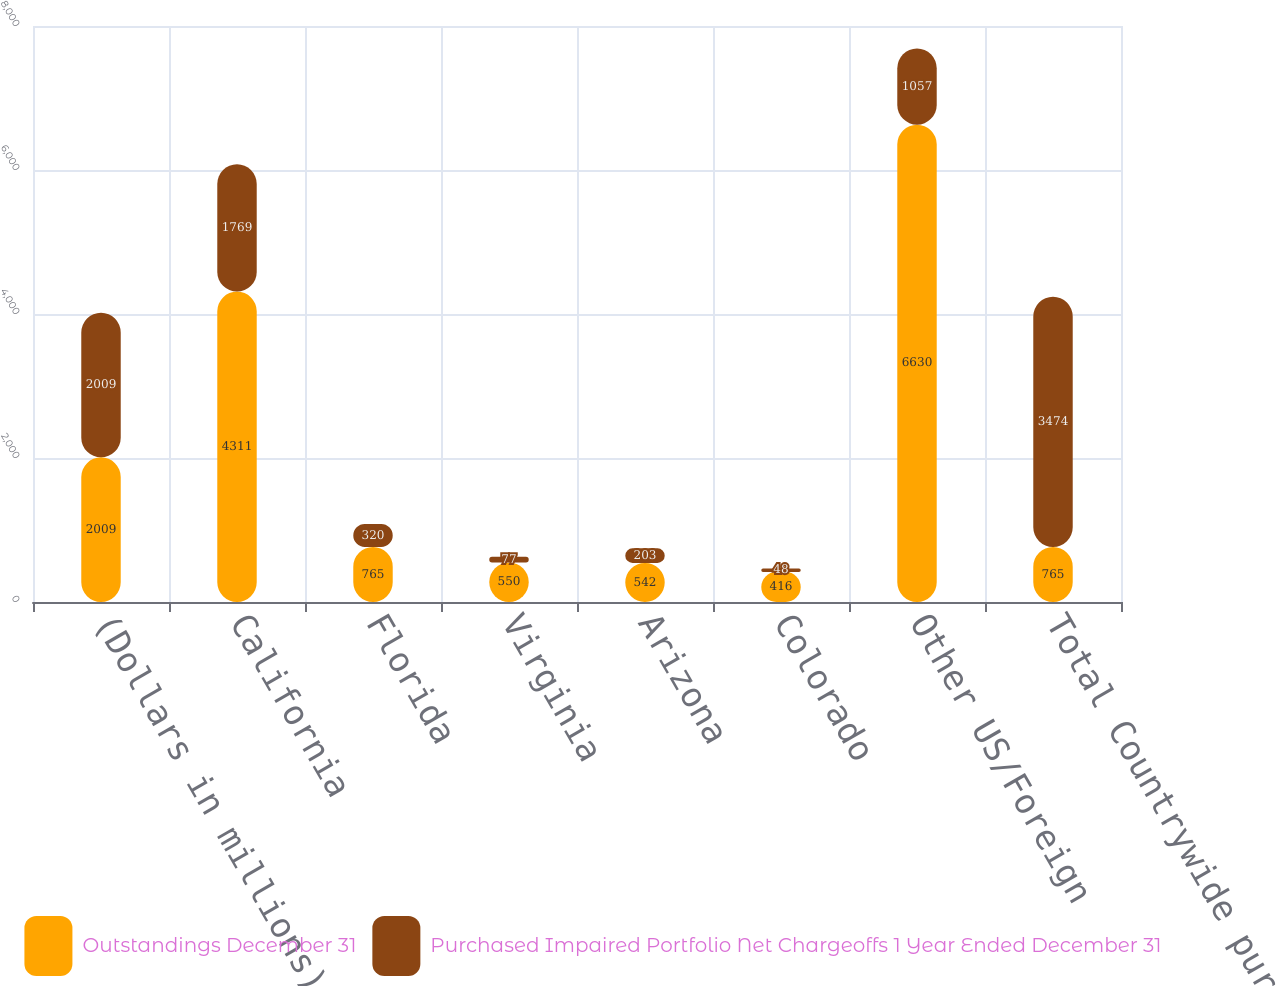Convert chart to OTSL. <chart><loc_0><loc_0><loc_500><loc_500><stacked_bar_chart><ecel><fcel>(Dollars in millions)<fcel>California<fcel>Florida<fcel>Virginia<fcel>Arizona<fcel>Colorado<fcel>Other US/Foreign<fcel>Total Countrywide purchased<nl><fcel>Outstandings December 31<fcel>2009<fcel>4311<fcel>765<fcel>550<fcel>542<fcel>416<fcel>6630<fcel>765<nl><fcel>Purchased Impaired Portfolio Net Chargeoffs 1 Year Ended December 31<fcel>2009<fcel>1769<fcel>320<fcel>77<fcel>203<fcel>48<fcel>1057<fcel>3474<nl></chart> 